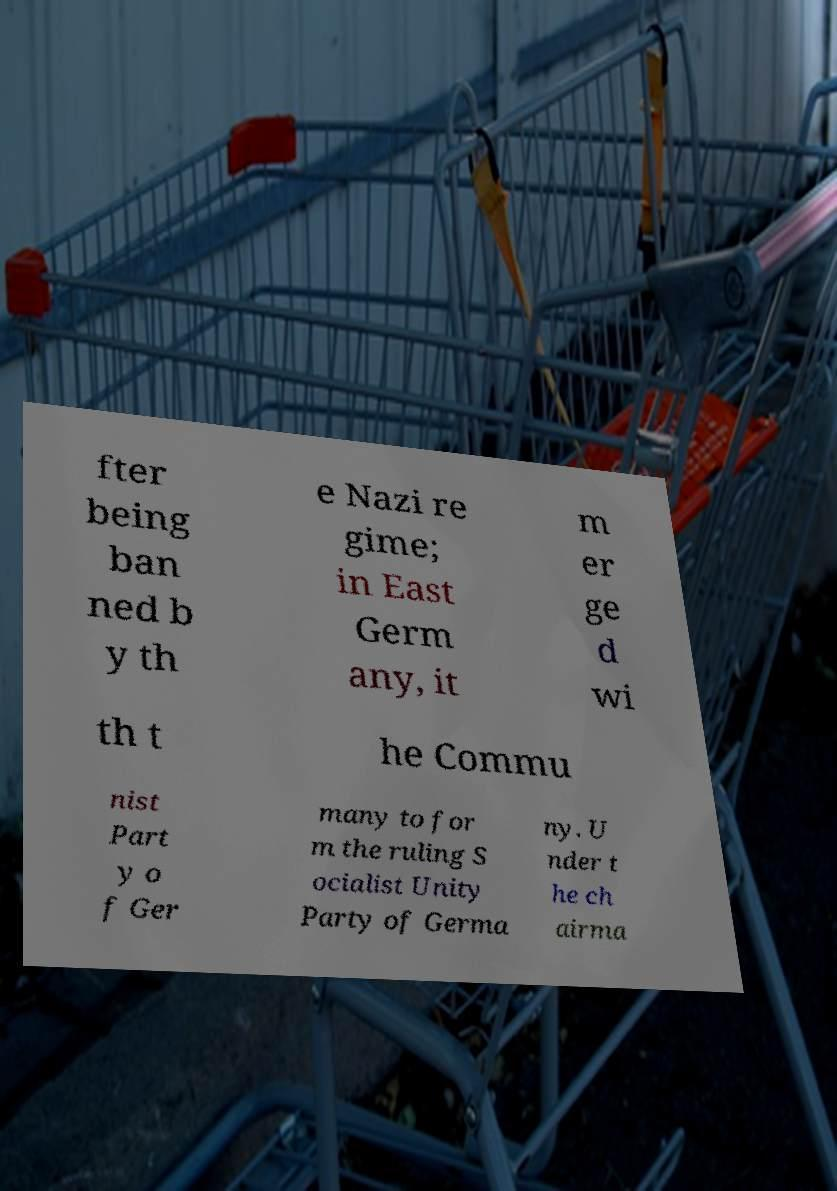What messages or text are displayed in this image? I need them in a readable, typed format. fter being ban ned b y th e Nazi re gime; in East Germ any, it m er ge d wi th t he Commu nist Part y o f Ger many to for m the ruling S ocialist Unity Party of Germa ny. U nder t he ch airma 